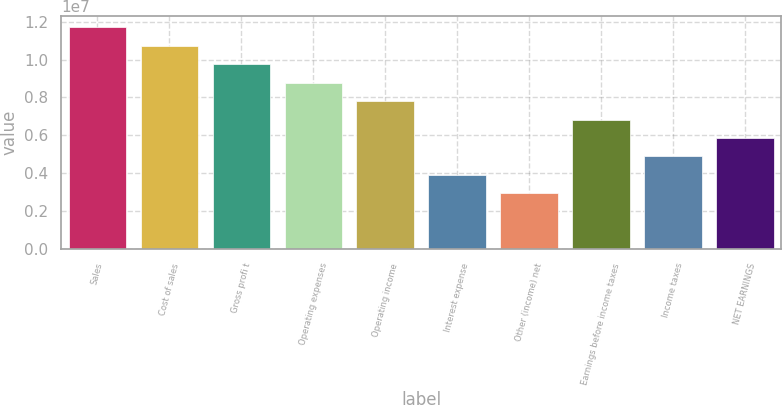Convert chart. <chart><loc_0><loc_0><loc_500><loc_500><bar_chart><fcel>Sales<fcel>Cost of sales<fcel>Gross profi t<fcel>Operating expenses<fcel>Operating income<fcel>Interest expense<fcel>Other (income) net<fcel>Earnings before income taxes<fcel>Income taxes<fcel>NET EARNINGS<nl><fcel>1.1714e+07<fcel>1.07378e+07<fcel>9.76166e+06<fcel>8.78549e+06<fcel>7.80933e+06<fcel>3.90466e+06<fcel>2.9285e+06<fcel>6.83316e+06<fcel>4.88083e+06<fcel>5.857e+06<nl></chart> 